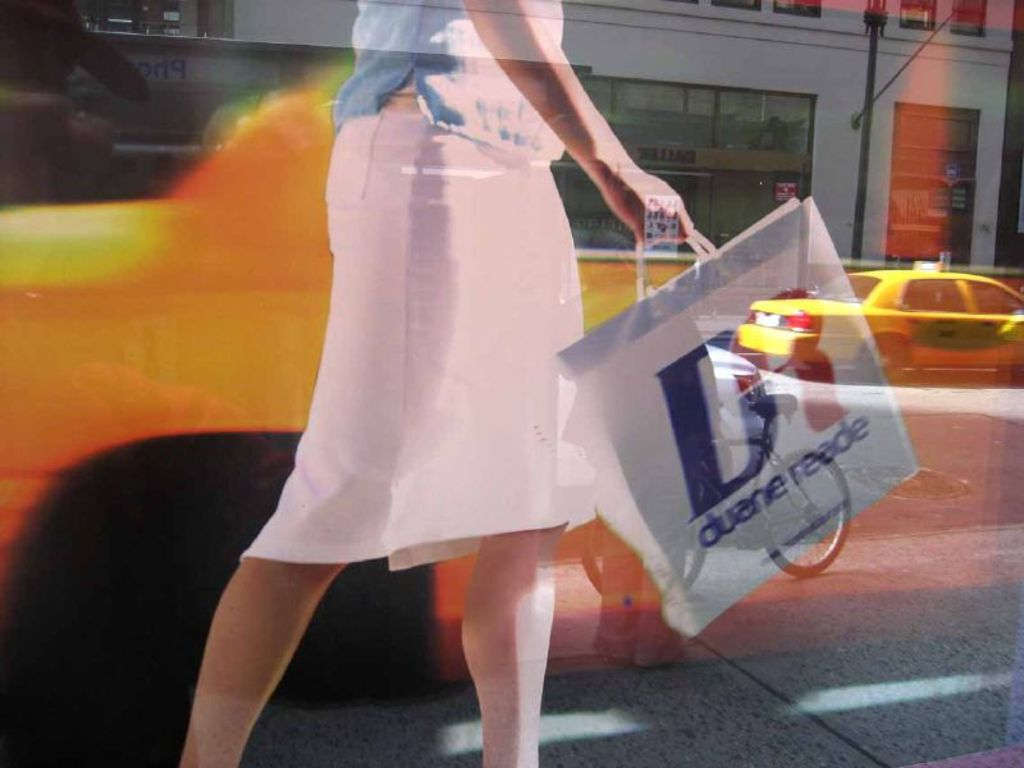What does the background suggest about the location where this photo was taken? The background, with its view of yellow taxis and busy streets, suggests that this photo was taken in a metropolitan area, likely in a city like New York given the presence of a 'Duane Reade' store. 